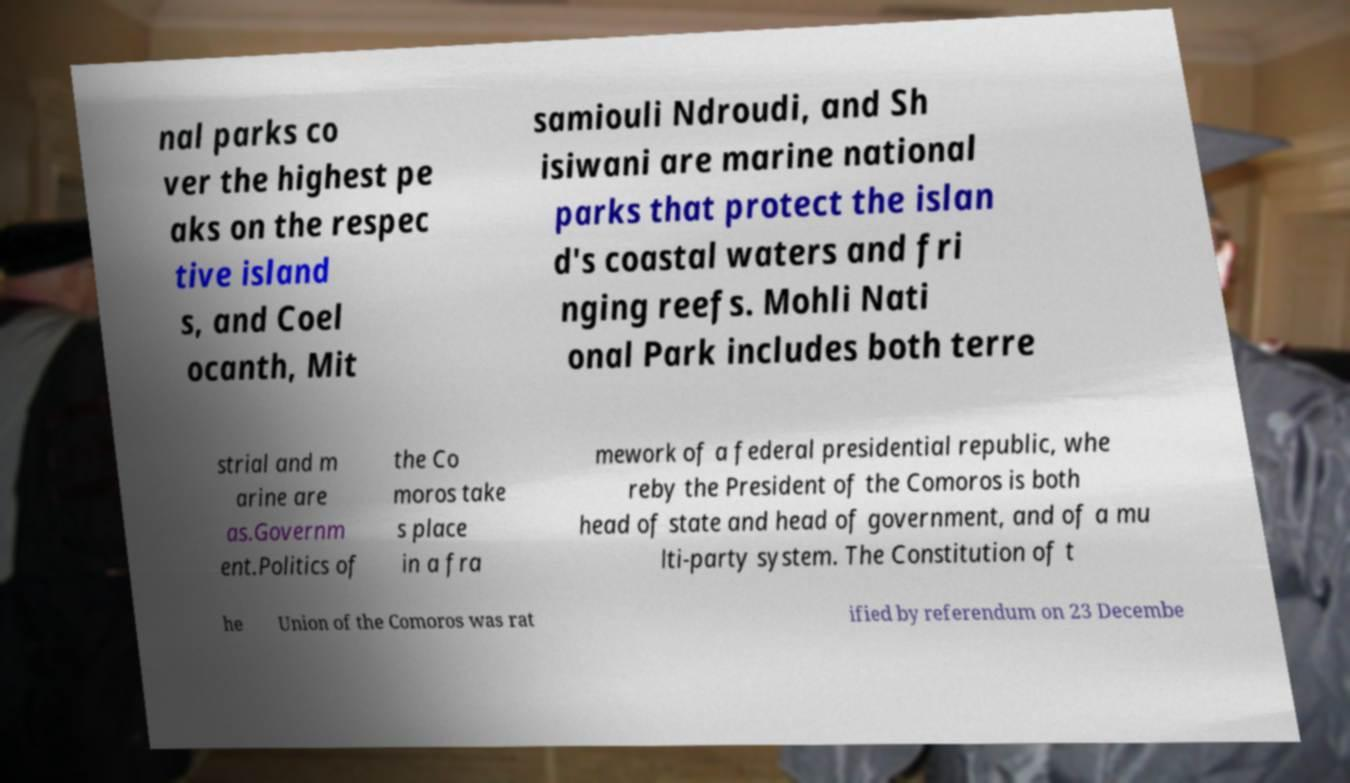Can you read and provide the text displayed in the image?This photo seems to have some interesting text. Can you extract and type it out for me? nal parks co ver the highest pe aks on the respec tive island s, and Coel ocanth, Mit samiouli Ndroudi, and Sh isiwani are marine national parks that protect the islan d's coastal waters and fri nging reefs. Mohli Nati onal Park includes both terre strial and m arine are as.Governm ent.Politics of the Co moros take s place in a fra mework of a federal presidential republic, whe reby the President of the Comoros is both head of state and head of government, and of a mu lti-party system. The Constitution of t he Union of the Comoros was rat ified by referendum on 23 Decembe 